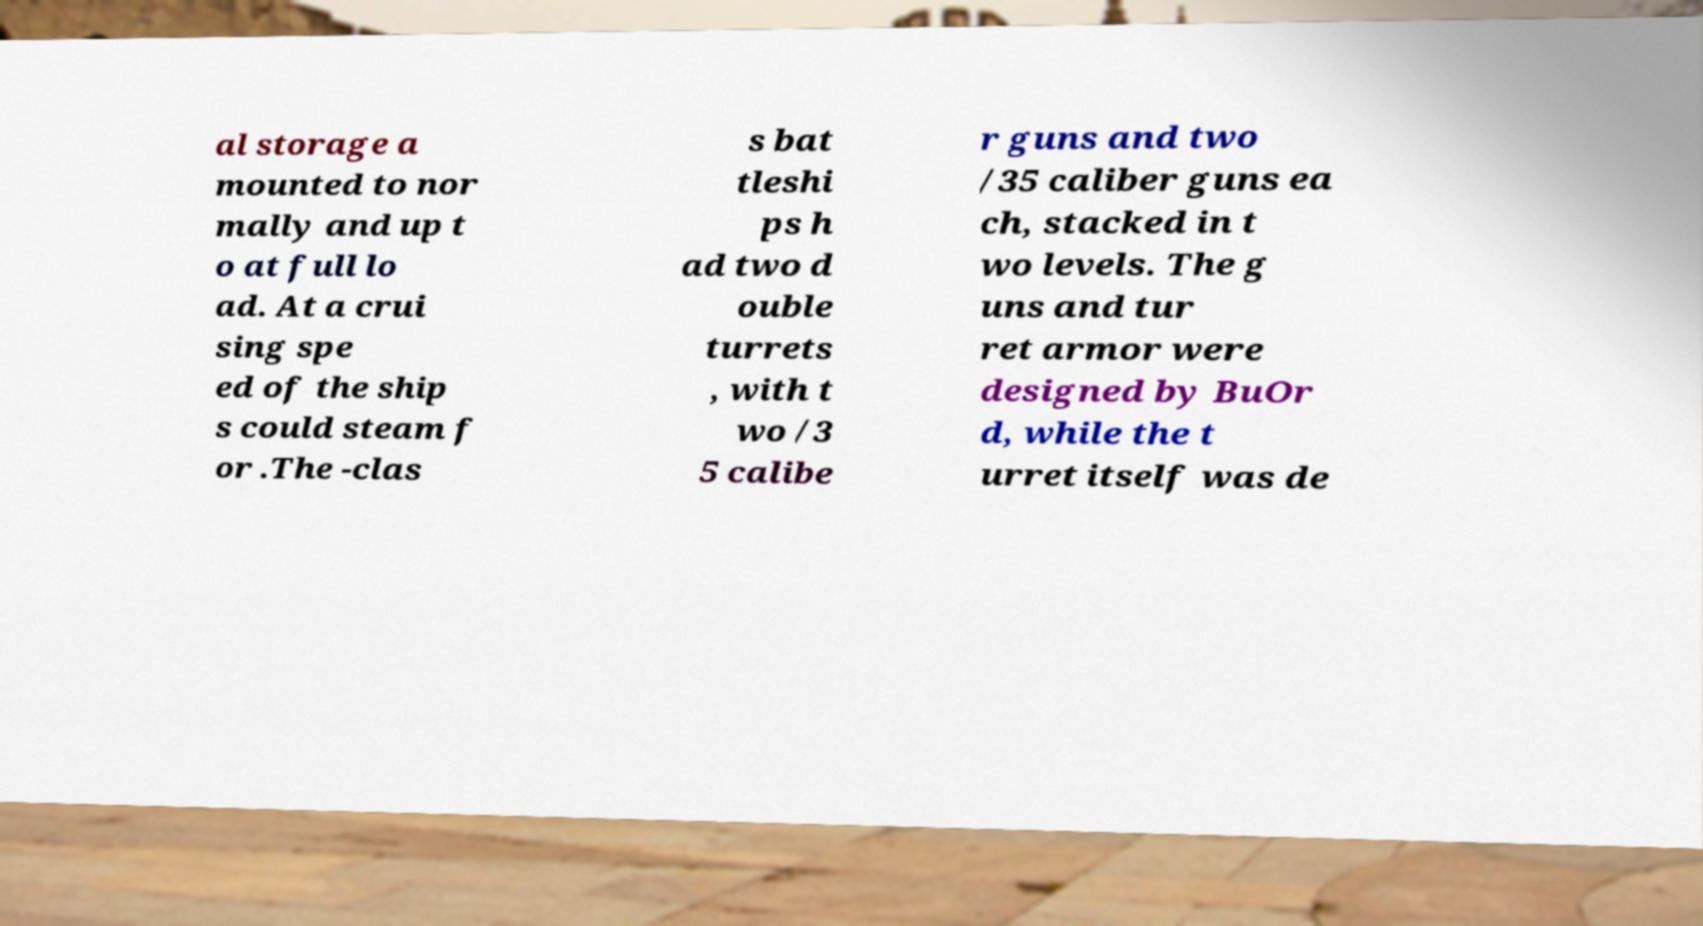Could you assist in decoding the text presented in this image and type it out clearly? al storage a mounted to nor mally and up t o at full lo ad. At a crui sing spe ed of the ship s could steam f or .The -clas s bat tleshi ps h ad two d ouble turrets , with t wo /3 5 calibe r guns and two /35 caliber guns ea ch, stacked in t wo levels. The g uns and tur ret armor were designed by BuOr d, while the t urret itself was de 